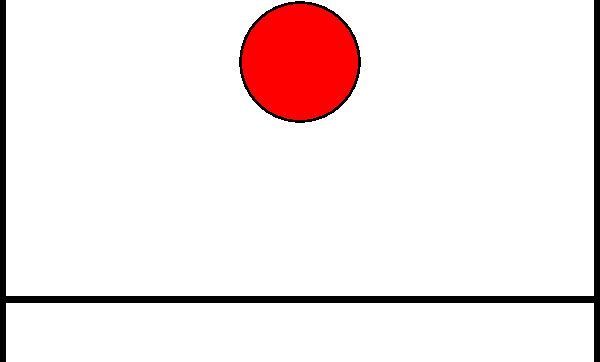In a thrilling scene from "The Incredible Hulk: Bridge Buster," the Hulk lands on a simple beam bridge, generating a massive impact force. The bridge span is 50 meters, and the Hulk's landing point is at the center. If the bridge's maximum allowable bending moment is 5000 kN·m and the Hulk's impact creates a concentrated load of F, what is the maximum force F that the bridge can withstand before failure? Let's approach this step-by-step:

1) For a simple beam with a concentrated load at the center, the maximum bending moment occurs at the center and is given by:

   $$M_{max} = \frac{FL}{4}$$

   Where F is the concentrated load and L is the span length.

2) We know the maximum allowable bending moment is 5000 kN·m and the span length is 50 m. Let's substitute these values:

   $$5000 = \frac{F \cdot 50}{4}$$

3) Now, let's solve for F:

   $$5000 = \frac{50F}{4}$$
   $$5000 = 12.5F$$

4) Divide both sides by 12.5:

   $$\frac{5000}{12.5} = F$$
   $$400 = F$$

5) Therefore, the maximum force F that the bridge can withstand is 400 kN.

This result means that if the Hulk's impact creates a force greater than 400 kN, the bridge will likely fail due to excessive bending moment.
Answer: 400 kN 